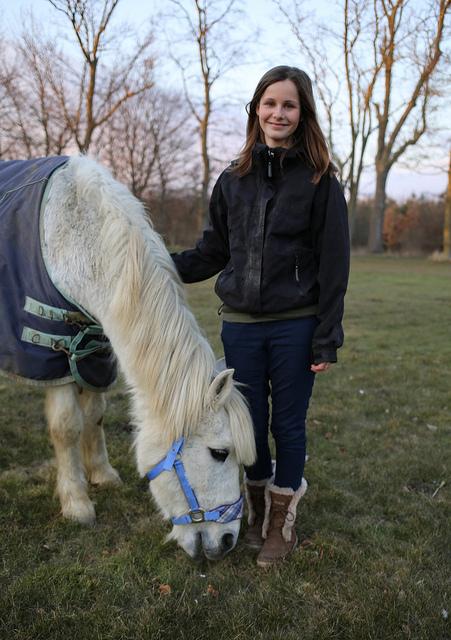What is the horse eating?
Write a very short answer. Grass. Is she wearing boots?
Concise answer only. Yes. What color is the horse?
Short answer required. White. 